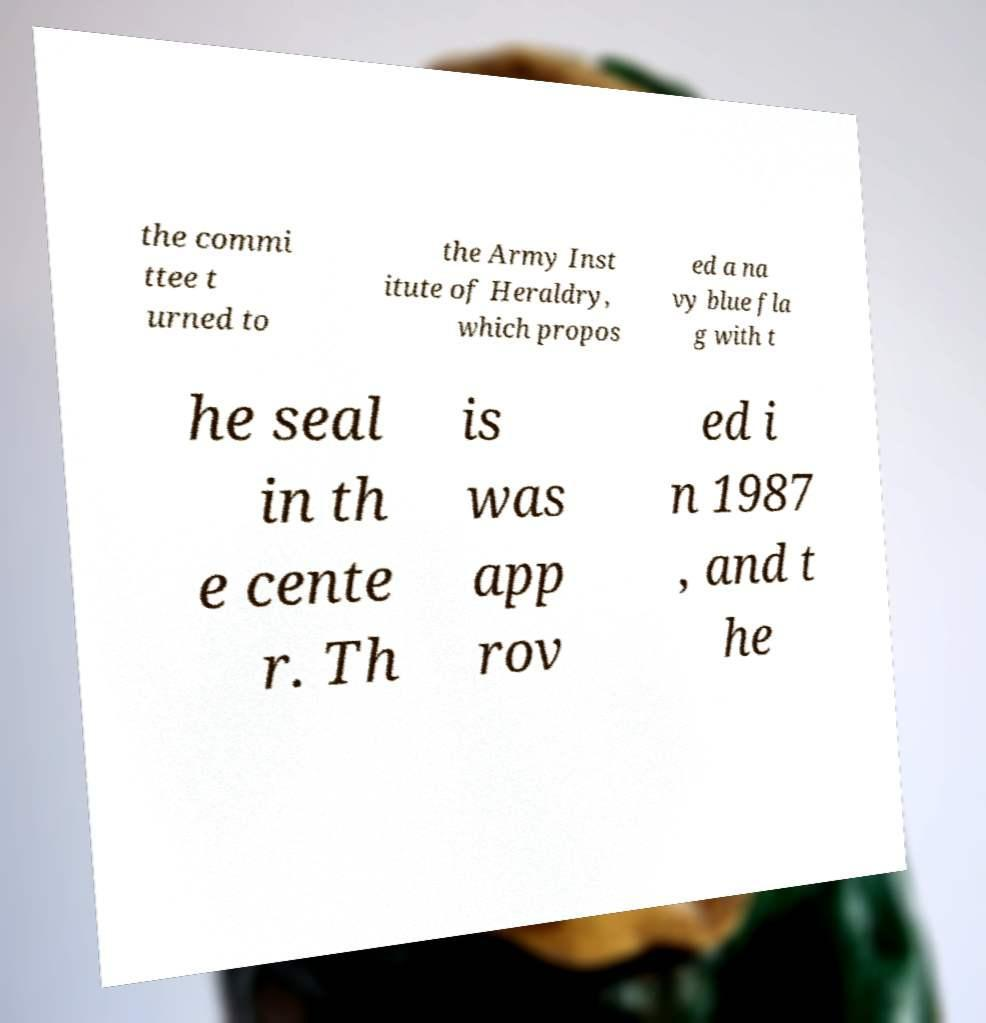Could you extract and type out the text from this image? the commi ttee t urned to the Army Inst itute of Heraldry, which propos ed a na vy blue fla g with t he seal in th e cente r. Th is was app rov ed i n 1987 , and t he 